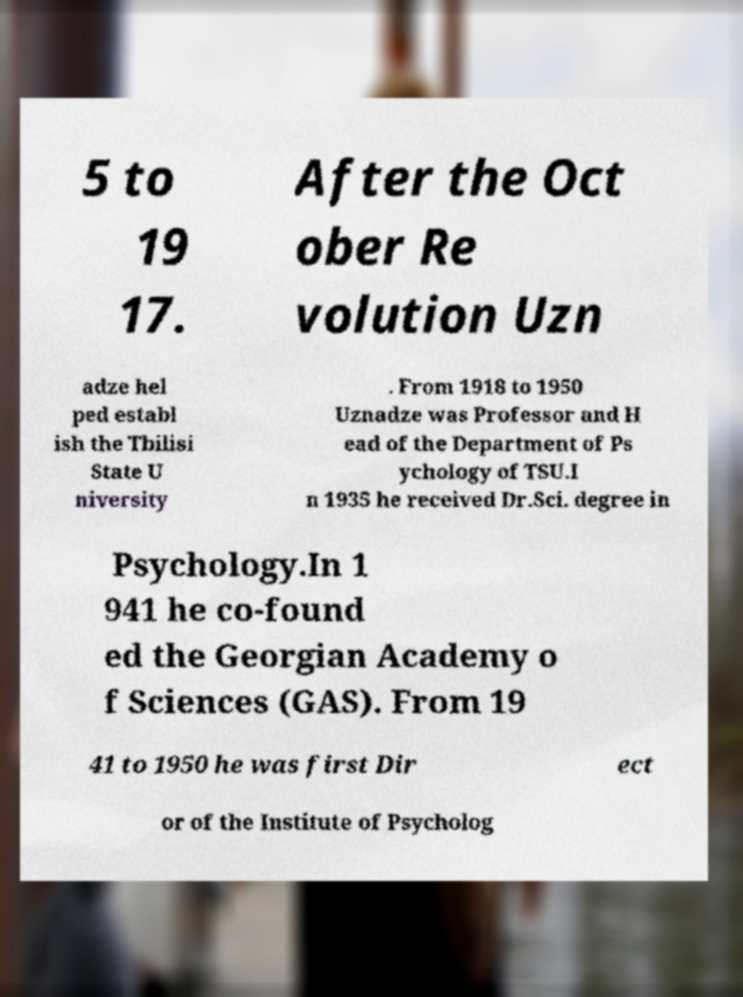What messages or text are displayed in this image? I need them in a readable, typed format. 5 to 19 17. After the Oct ober Re volution Uzn adze hel ped establ ish the Tbilisi State U niversity . From 1918 to 1950 Uznadze was Professor and H ead of the Department of Ps ychology of TSU.I n 1935 he received Dr.Sci. degree in Psychology.In 1 941 he co-found ed the Georgian Academy o f Sciences (GAS). From 19 41 to 1950 he was first Dir ect or of the Institute of Psycholog 